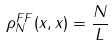<formula> <loc_0><loc_0><loc_500><loc_500>\rho _ { N } ^ { F F } ( x , x ) = \frac { N } { L }</formula> 